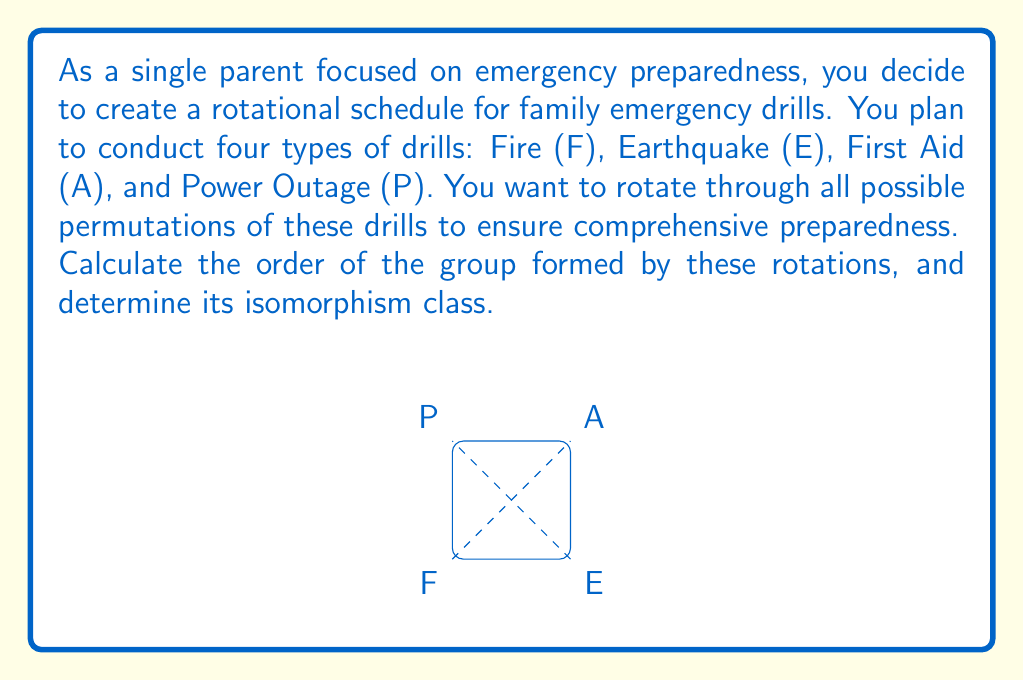Give your solution to this math problem. Let's approach this step-by-step:

1) First, we need to determine the number of possible permutations of the four drill types (F, E, A, P). This is given by 4! = 4 × 3 × 2 × 1 = 24.

2) The rotations of these permutations form a group. Each rotation corresponds to a permutation of the drill order.

3) The group of permutations on 4 elements is known as the symmetric group S₄.

4) The order of S₄ is 24, which matches our calculation in step 1.

5) To determine the isomorphism class, we need to consider the properties of S₄:
   - It is non-abelian (not all permutations commute)
   - It has elements of order 2, 3, and 4
   - It is not isomorphic to A₄ (the alternating group on 4 elements) or D₄ (the dihedral group of order 8)

6) Given these properties, we can conclude that the group is isomorphic to S₄ itself.

Therefore, the group formed by the rotations of the emergency drill schedule has order 24 and is isomorphic to S₄.
Answer: Order: 24, Isomorphic to $S_4$ 